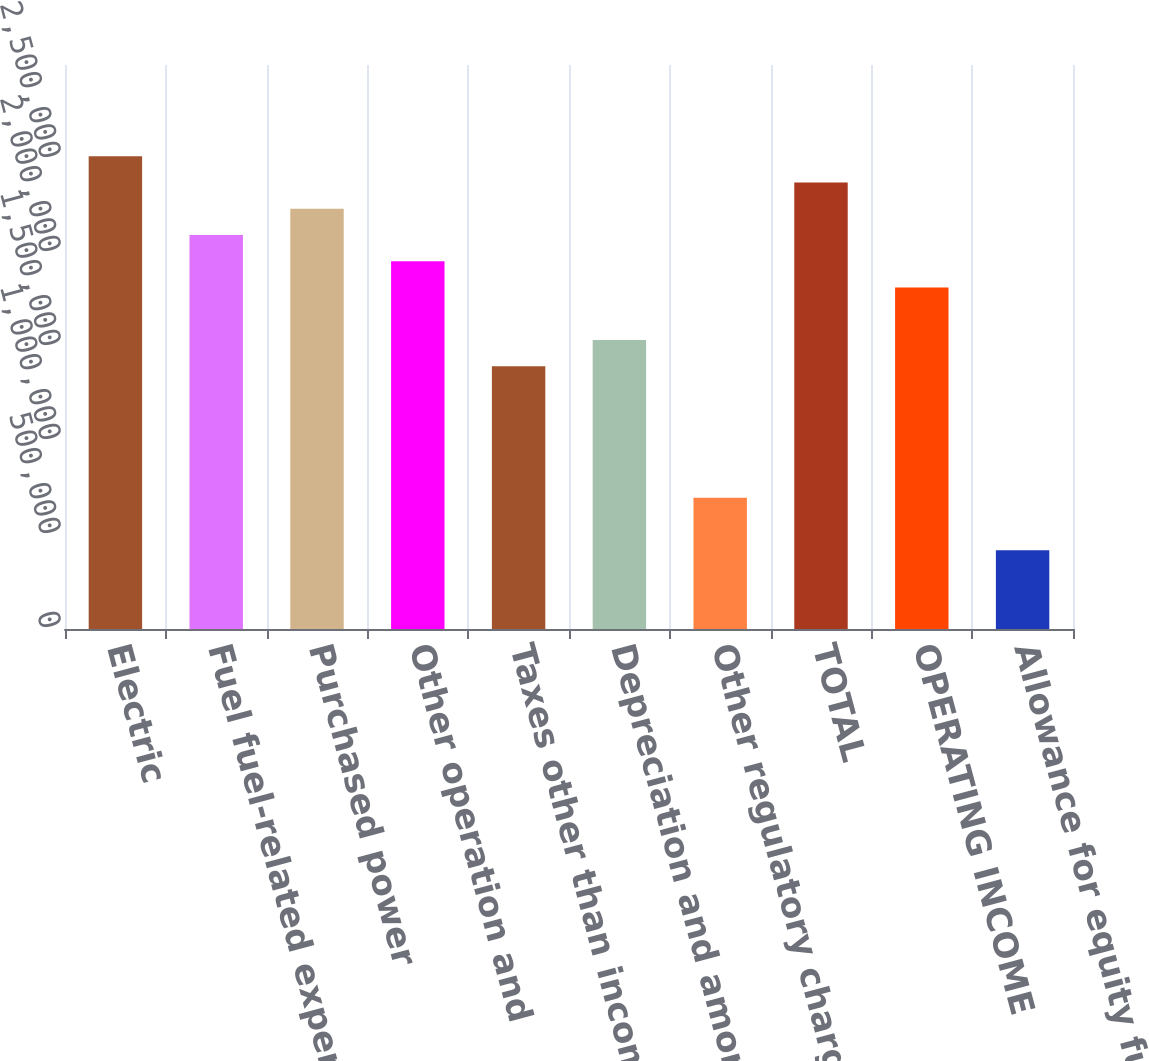Convert chart. <chart><loc_0><loc_0><loc_500><loc_500><bar_chart><fcel>Electric<fcel>Fuel fuel-related expenses and<fcel>Purchased power<fcel>Other operation and<fcel>Taxes other than income taxes<fcel>Depreciation and amortization<fcel>Other regulatory charges<fcel>TOTAL<fcel>OPERATING INCOME<fcel>Allowance for equity funds<nl><fcel>2.51442e+06<fcel>2.09538e+06<fcel>2.23506e+06<fcel>1.9557e+06<fcel>1.39698e+06<fcel>1.53666e+06<fcel>698590<fcel>2.37474e+06<fcel>1.81602e+06<fcel>419232<nl></chart> 